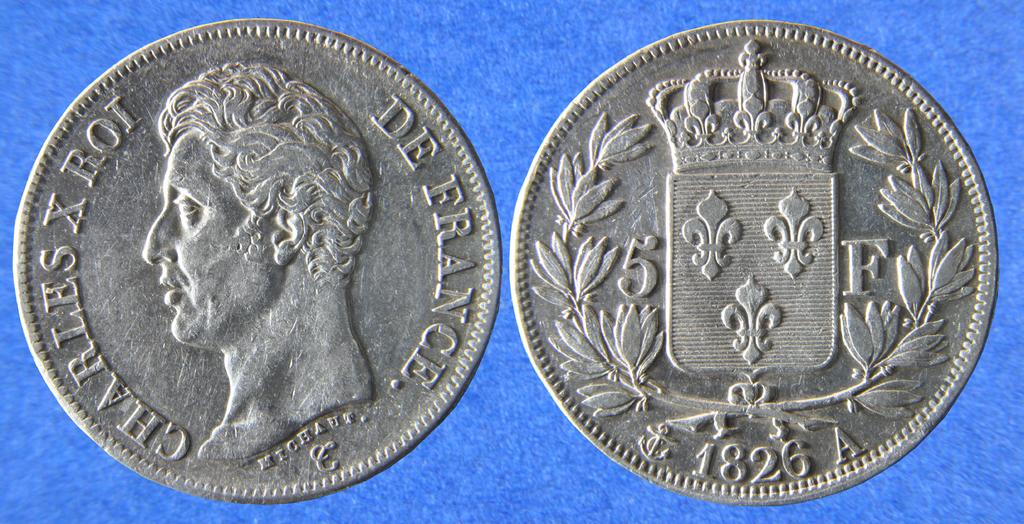What year is this coin from?
Make the answer very short. 1826. What is the letter after the date?
Keep it short and to the point. A. 